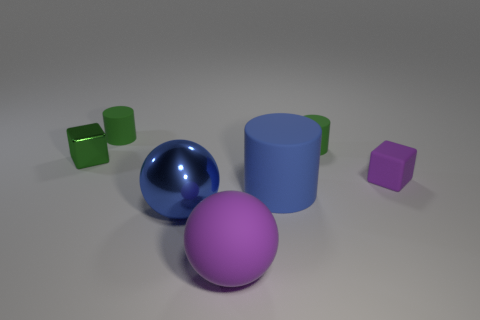Subtract all green cylinders. How many cylinders are left? 1 Subtract all green matte cylinders. How many cylinders are left? 1 Add 4 big matte objects. How many big matte objects exist? 6 Add 2 green matte things. How many objects exist? 9 Subtract 0 green balls. How many objects are left? 7 Subtract all blocks. How many objects are left? 5 Subtract 1 blocks. How many blocks are left? 1 Subtract all blue cubes. Subtract all green cylinders. How many cubes are left? 2 Subtract all cyan balls. How many green cylinders are left? 2 Subtract all purple matte balls. Subtract all matte blocks. How many objects are left? 5 